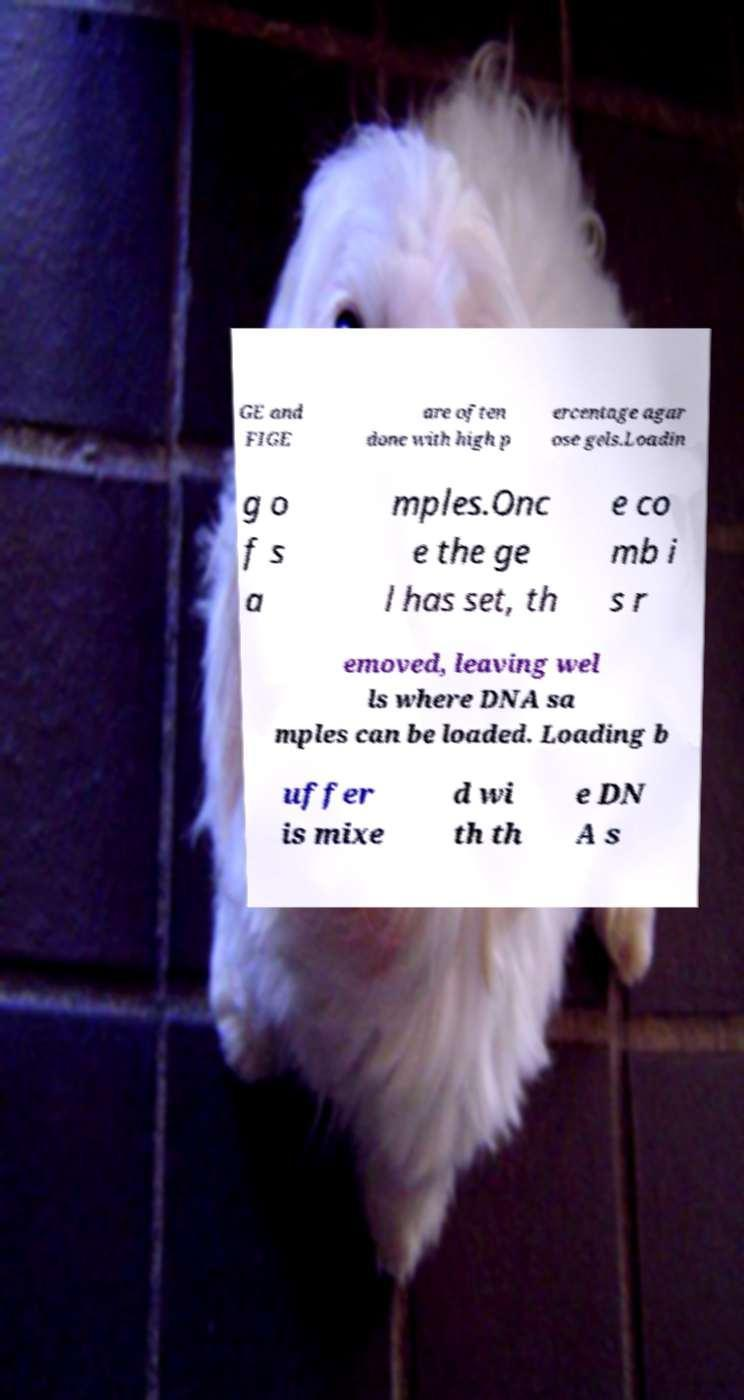What messages or text are displayed in this image? I need them in a readable, typed format. GE and FIGE are often done with high p ercentage agar ose gels.Loadin g o f s a mples.Onc e the ge l has set, th e co mb i s r emoved, leaving wel ls where DNA sa mples can be loaded. Loading b uffer is mixe d wi th th e DN A s 